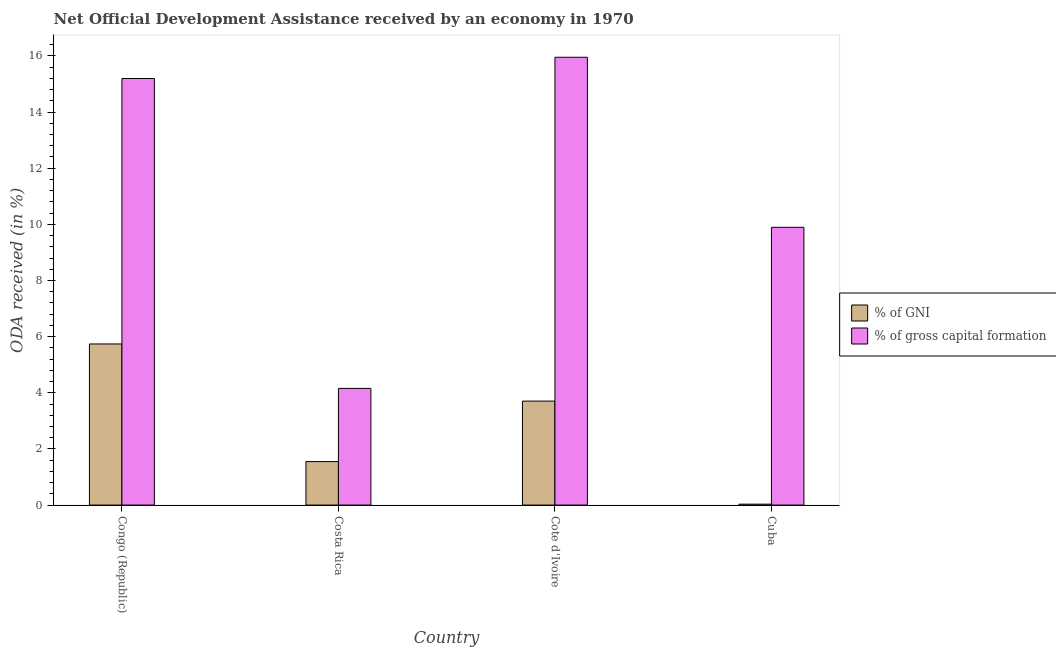How many different coloured bars are there?
Your response must be concise. 2. How many groups of bars are there?
Keep it short and to the point. 4. Are the number of bars per tick equal to the number of legend labels?
Your answer should be compact. Yes. Are the number of bars on each tick of the X-axis equal?
Offer a terse response. Yes. How many bars are there on the 4th tick from the right?
Provide a succinct answer. 2. What is the label of the 2nd group of bars from the left?
Make the answer very short. Costa Rica. What is the oda received as percentage of gni in Costa Rica?
Offer a terse response. 1.55. Across all countries, what is the maximum oda received as percentage of gross capital formation?
Keep it short and to the point. 15.95. Across all countries, what is the minimum oda received as percentage of gni?
Give a very brief answer. 0.03. In which country was the oda received as percentage of gross capital formation maximum?
Ensure brevity in your answer.  Cote d'Ivoire. What is the total oda received as percentage of gross capital formation in the graph?
Provide a short and direct response. 45.2. What is the difference between the oda received as percentage of gross capital formation in Congo (Republic) and that in Cuba?
Offer a very short reply. 5.3. What is the difference between the oda received as percentage of gni in Cuba and the oda received as percentage of gross capital formation in Costa Rica?
Offer a terse response. -4.12. What is the average oda received as percentage of gross capital formation per country?
Provide a succinct answer. 11.3. What is the difference between the oda received as percentage of gross capital formation and oda received as percentage of gni in Cote d'Ivoire?
Keep it short and to the point. 12.25. In how many countries, is the oda received as percentage of gni greater than 8.8 %?
Keep it short and to the point. 0. What is the ratio of the oda received as percentage of gni in Congo (Republic) to that in Costa Rica?
Your response must be concise. 3.71. What is the difference between the highest and the second highest oda received as percentage of gni?
Make the answer very short. 2.04. What is the difference between the highest and the lowest oda received as percentage of gni?
Your answer should be compact. 5.71. In how many countries, is the oda received as percentage of gross capital formation greater than the average oda received as percentage of gross capital formation taken over all countries?
Make the answer very short. 2. Is the sum of the oda received as percentage of gni in Costa Rica and Cote d'Ivoire greater than the maximum oda received as percentage of gross capital formation across all countries?
Provide a short and direct response. No. What does the 1st bar from the left in Cote d'Ivoire represents?
Make the answer very short. % of GNI. What does the 1st bar from the right in Cote d'Ivoire represents?
Ensure brevity in your answer.  % of gross capital formation. How many bars are there?
Ensure brevity in your answer.  8. Are all the bars in the graph horizontal?
Offer a very short reply. No. How many countries are there in the graph?
Give a very brief answer. 4. What is the difference between two consecutive major ticks on the Y-axis?
Make the answer very short. 2. Does the graph contain any zero values?
Offer a very short reply. No. Does the graph contain grids?
Offer a very short reply. No. Where does the legend appear in the graph?
Keep it short and to the point. Center right. How many legend labels are there?
Provide a succinct answer. 2. How are the legend labels stacked?
Provide a succinct answer. Vertical. What is the title of the graph?
Your response must be concise. Net Official Development Assistance received by an economy in 1970. Does "By country of asylum" appear as one of the legend labels in the graph?
Make the answer very short. No. What is the label or title of the X-axis?
Your answer should be compact. Country. What is the label or title of the Y-axis?
Provide a succinct answer. ODA received (in %). What is the ODA received (in %) in % of GNI in Congo (Republic)?
Make the answer very short. 5.74. What is the ODA received (in %) of % of gross capital formation in Congo (Republic)?
Offer a terse response. 15.2. What is the ODA received (in %) in % of GNI in Costa Rica?
Keep it short and to the point. 1.55. What is the ODA received (in %) in % of gross capital formation in Costa Rica?
Provide a short and direct response. 4.16. What is the ODA received (in %) of % of GNI in Cote d'Ivoire?
Give a very brief answer. 3.7. What is the ODA received (in %) of % of gross capital formation in Cote d'Ivoire?
Ensure brevity in your answer.  15.95. What is the ODA received (in %) of % of GNI in Cuba?
Provide a succinct answer. 0.03. What is the ODA received (in %) in % of gross capital formation in Cuba?
Give a very brief answer. 9.89. Across all countries, what is the maximum ODA received (in %) in % of GNI?
Your answer should be compact. 5.74. Across all countries, what is the maximum ODA received (in %) of % of gross capital formation?
Give a very brief answer. 15.95. Across all countries, what is the minimum ODA received (in %) in % of GNI?
Make the answer very short. 0.03. Across all countries, what is the minimum ODA received (in %) of % of gross capital formation?
Ensure brevity in your answer.  4.16. What is the total ODA received (in %) of % of GNI in the graph?
Your answer should be very brief. 11.02. What is the total ODA received (in %) of % of gross capital formation in the graph?
Keep it short and to the point. 45.2. What is the difference between the ODA received (in %) of % of GNI in Congo (Republic) and that in Costa Rica?
Keep it short and to the point. 4.19. What is the difference between the ODA received (in %) of % of gross capital formation in Congo (Republic) and that in Costa Rica?
Ensure brevity in your answer.  11.04. What is the difference between the ODA received (in %) in % of GNI in Congo (Republic) and that in Cote d'Ivoire?
Your answer should be compact. 2.04. What is the difference between the ODA received (in %) of % of gross capital formation in Congo (Republic) and that in Cote d'Ivoire?
Your response must be concise. -0.76. What is the difference between the ODA received (in %) in % of GNI in Congo (Republic) and that in Cuba?
Give a very brief answer. 5.71. What is the difference between the ODA received (in %) in % of gross capital formation in Congo (Republic) and that in Cuba?
Give a very brief answer. 5.3. What is the difference between the ODA received (in %) of % of GNI in Costa Rica and that in Cote d'Ivoire?
Provide a succinct answer. -2.15. What is the difference between the ODA received (in %) of % of gross capital formation in Costa Rica and that in Cote d'Ivoire?
Provide a succinct answer. -11.8. What is the difference between the ODA received (in %) of % of GNI in Costa Rica and that in Cuba?
Provide a succinct answer. 1.52. What is the difference between the ODA received (in %) of % of gross capital formation in Costa Rica and that in Cuba?
Provide a short and direct response. -5.74. What is the difference between the ODA received (in %) in % of GNI in Cote d'Ivoire and that in Cuba?
Provide a short and direct response. 3.67. What is the difference between the ODA received (in %) of % of gross capital formation in Cote d'Ivoire and that in Cuba?
Give a very brief answer. 6.06. What is the difference between the ODA received (in %) in % of GNI in Congo (Republic) and the ODA received (in %) in % of gross capital formation in Costa Rica?
Offer a very short reply. 1.58. What is the difference between the ODA received (in %) of % of GNI in Congo (Republic) and the ODA received (in %) of % of gross capital formation in Cote d'Ivoire?
Your response must be concise. -10.21. What is the difference between the ODA received (in %) in % of GNI in Congo (Republic) and the ODA received (in %) in % of gross capital formation in Cuba?
Make the answer very short. -4.16. What is the difference between the ODA received (in %) in % of GNI in Costa Rica and the ODA received (in %) in % of gross capital formation in Cote d'Ivoire?
Keep it short and to the point. -14.4. What is the difference between the ODA received (in %) of % of GNI in Costa Rica and the ODA received (in %) of % of gross capital formation in Cuba?
Provide a short and direct response. -8.35. What is the difference between the ODA received (in %) in % of GNI in Cote d'Ivoire and the ODA received (in %) in % of gross capital formation in Cuba?
Provide a succinct answer. -6.19. What is the average ODA received (in %) in % of GNI per country?
Ensure brevity in your answer.  2.76. What is the average ODA received (in %) of % of gross capital formation per country?
Your response must be concise. 11.3. What is the difference between the ODA received (in %) of % of GNI and ODA received (in %) of % of gross capital formation in Congo (Republic)?
Provide a short and direct response. -9.46. What is the difference between the ODA received (in %) in % of GNI and ODA received (in %) in % of gross capital formation in Costa Rica?
Provide a succinct answer. -2.61. What is the difference between the ODA received (in %) of % of GNI and ODA received (in %) of % of gross capital formation in Cote d'Ivoire?
Give a very brief answer. -12.25. What is the difference between the ODA received (in %) of % of GNI and ODA received (in %) of % of gross capital formation in Cuba?
Your answer should be very brief. -9.86. What is the ratio of the ODA received (in %) of % of GNI in Congo (Republic) to that in Costa Rica?
Your answer should be compact. 3.71. What is the ratio of the ODA received (in %) in % of gross capital formation in Congo (Republic) to that in Costa Rica?
Give a very brief answer. 3.66. What is the ratio of the ODA received (in %) in % of GNI in Congo (Republic) to that in Cote d'Ivoire?
Give a very brief answer. 1.55. What is the ratio of the ODA received (in %) in % of gross capital formation in Congo (Republic) to that in Cote d'Ivoire?
Give a very brief answer. 0.95. What is the ratio of the ODA received (in %) in % of GNI in Congo (Republic) to that in Cuba?
Give a very brief answer. 176.08. What is the ratio of the ODA received (in %) of % of gross capital formation in Congo (Republic) to that in Cuba?
Offer a very short reply. 1.54. What is the ratio of the ODA received (in %) of % of GNI in Costa Rica to that in Cote d'Ivoire?
Provide a succinct answer. 0.42. What is the ratio of the ODA received (in %) in % of gross capital formation in Costa Rica to that in Cote d'Ivoire?
Offer a terse response. 0.26. What is the ratio of the ODA received (in %) in % of GNI in Costa Rica to that in Cuba?
Your answer should be very brief. 47.52. What is the ratio of the ODA received (in %) in % of gross capital formation in Costa Rica to that in Cuba?
Offer a terse response. 0.42. What is the ratio of the ODA received (in %) of % of GNI in Cote d'Ivoire to that in Cuba?
Ensure brevity in your answer.  113.64. What is the ratio of the ODA received (in %) of % of gross capital formation in Cote d'Ivoire to that in Cuba?
Your answer should be very brief. 1.61. What is the difference between the highest and the second highest ODA received (in %) of % of GNI?
Ensure brevity in your answer.  2.04. What is the difference between the highest and the second highest ODA received (in %) of % of gross capital formation?
Offer a terse response. 0.76. What is the difference between the highest and the lowest ODA received (in %) of % of GNI?
Keep it short and to the point. 5.71. What is the difference between the highest and the lowest ODA received (in %) in % of gross capital formation?
Your response must be concise. 11.8. 